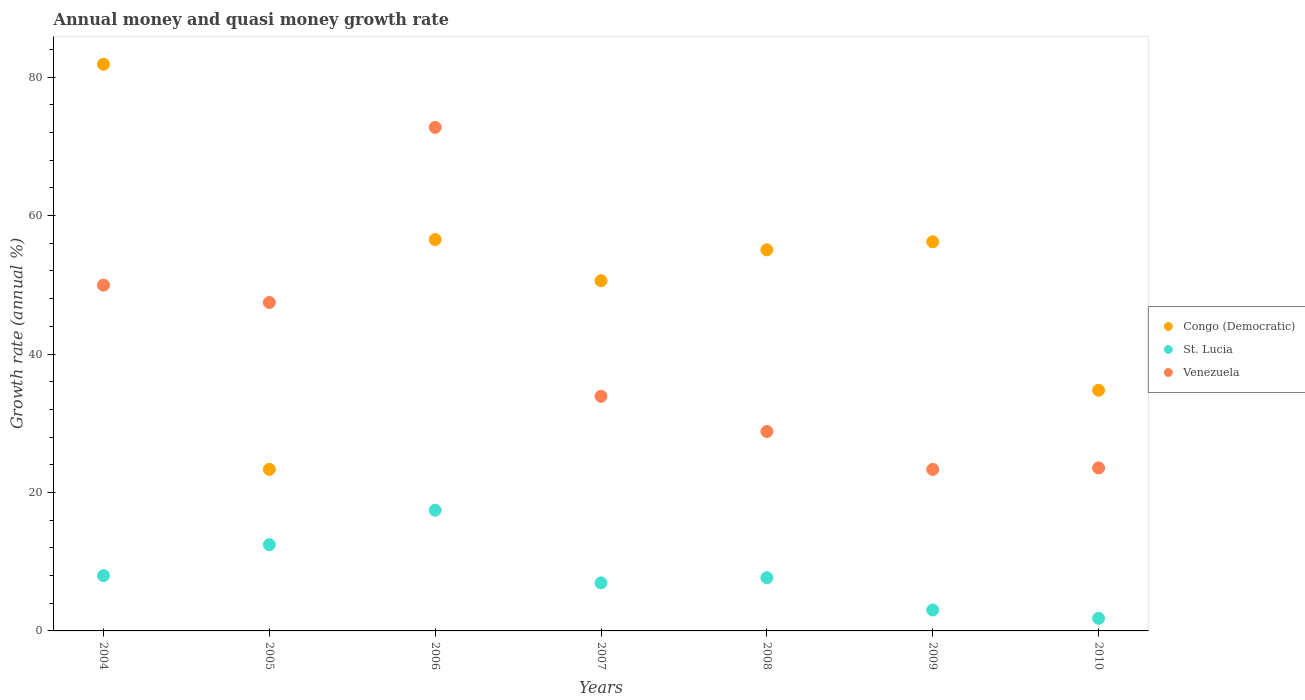Is the number of dotlines equal to the number of legend labels?
Keep it short and to the point. Yes. What is the growth rate in St. Lucia in 2009?
Your answer should be very brief. 3.03. Across all years, what is the maximum growth rate in Venezuela?
Ensure brevity in your answer.  72.74. Across all years, what is the minimum growth rate in Venezuela?
Make the answer very short. 23.33. In which year was the growth rate in Venezuela maximum?
Ensure brevity in your answer.  2006. What is the total growth rate in St. Lucia in the graph?
Ensure brevity in your answer.  57.36. What is the difference between the growth rate in St. Lucia in 2007 and that in 2010?
Your response must be concise. 5.12. What is the difference between the growth rate in St. Lucia in 2007 and the growth rate in Venezuela in 2008?
Your answer should be compact. -21.86. What is the average growth rate in Venezuela per year?
Offer a terse response. 39.96. In the year 2005, what is the difference between the growth rate in Congo (Democratic) and growth rate in Venezuela?
Your response must be concise. -24.1. In how many years, is the growth rate in St. Lucia greater than 76 %?
Make the answer very short. 0. What is the ratio of the growth rate in Congo (Democratic) in 2004 to that in 2009?
Give a very brief answer. 1.46. Is the difference between the growth rate in Congo (Democratic) in 2005 and 2010 greater than the difference between the growth rate in Venezuela in 2005 and 2010?
Make the answer very short. No. What is the difference between the highest and the second highest growth rate in St. Lucia?
Ensure brevity in your answer.  4.98. What is the difference between the highest and the lowest growth rate in Venezuela?
Keep it short and to the point. 49.4. In how many years, is the growth rate in St. Lucia greater than the average growth rate in St. Lucia taken over all years?
Provide a succinct answer. 2. Does the growth rate in Congo (Democratic) monotonically increase over the years?
Your answer should be very brief. No. How many dotlines are there?
Make the answer very short. 3. What is the difference between two consecutive major ticks on the Y-axis?
Give a very brief answer. 20. Does the graph contain any zero values?
Give a very brief answer. No. Where does the legend appear in the graph?
Offer a very short reply. Center right. How many legend labels are there?
Offer a very short reply. 3. How are the legend labels stacked?
Offer a terse response. Vertical. What is the title of the graph?
Ensure brevity in your answer.  Annual money and quasi money growth rate. Does "Iran" appear as one of the legend labels in the graph?
Ensure brevity in your answer.  No. What is the label or title of the X-axis?
Your response must be concise. Years. What is the label or title of the Y-axis?
Your answer should be very brief. Growth rate (annual %). What is the Growth rate (annual %) in Congo (Democratic) in 2004?
Give a very brief answer. 81.85. What is the Growth rate (annual %) of St. Lucia in 2004?
Give a very brief answer. 7.99. What is the Growth rate (annual %) of Venezuela in 2004?
Make the answer very short. 49.95. What is the Growth rate (annual %) of Congo (Democratic) in 2005?
Your answer should be compact. 23.34. What is the Growth rate (annual %) in St. Lucia in 2005?
Make the answer very short. 12.46. What is the Growth rate (annual %) in Venezuela in 2005?
Make the answer very short. 47.44. What is the Growth rate (annual %) in Congo (Democratic) in 2006?
Your response must be concise. 56.53. What is the Growth rate (annual %) of St. Lucia in 2006?
Your response must be concise. 17.43. What is the Growth rate (annual %) of Venezuela in 2006?
Your response must be concise. 72.74. What is the Growth rate (annual %) of Congo (Democratic) in 2007?
Keep it short and to the point. 50.59. What is the Growth rate (annual %) in St. Lucia in 2007?
Your response must be concise. 6.95. What is the Growth rate (annual %) in Venezuela in 2007?
Provide a short and direct response. 33.89. What is the Growth rate (annual %) of Congo (Democratic) in 2008?
Your answer should be very brief. 55.05. What is the Growth rate (annual %) in St. Lucia in 2008?
Make the answer very short. 7.69. What is the Growth rate (annual %) of Venezuela in 2008?
Ensure brevity in your answer.  28.8. What is the Growth rate (annual %) in Congo (Democratic) in 2009?
Keep it short and to the point. 56.21. What is the Growth rate (annual %) in St. Lucia in 2009?
Offer a terse response. 3.03. What is the Growth rate (annual %) in Venezuela in 2009?
Your answer should be compact. 23.33. What is the Growth rate (annual %) in Congo (Democratic) in 2010?
Offer a terse response. 34.76. What is the Growth rate (annual %) of St. Lucia in 2010?
Your response must be concise. 1.82. What is the Growth rate (annual %) of Venezuela in 2010?
Ensure brevity in your answer.  23.55. Across all years, what is the maximum Growth rate (annual %) of Congo (Democratic)?
Your response must be concise. 81.85. Across all years, what is the maximum Growth rate (annual %) of St. Lucia?
Give a very brief answer. 17.43. Across all years, what is the maximum Growth rate (annual %) in Venezuela?
Offer a very short reply. 72.74. Across all years, what is the minimum Growth rate (annual %) in Congo (Democratic)?
Your response must be concise. 23.34. Across all years, what is the minimum Growth rate (annual %) of St. Lucia?
Keep it short and to the point. 1.82. Across all years, what is the minimum Growth rate (annual %) in Venezuela?
Ensure brevity in your answer.  23.33. What is the total Growth rate (annual %) of Congo (Democratic) in the graph?
Offer a terse response. 358.34. What is the total Growth rate (annual %) of St. Lucia in the graph?
Your answer should be compact. 57.36. What is the total Growth rate (annual %) of Venezuela in the graph?
Offer a very short reply. 279.7. What is the difference between the Growth rate (annual %) of Congo (Democratic) in 2004 and that in 2005?
Your answer should be very brief. 58.51. What is the difference between the Growth rate (annual %) in St. Lucia in 2004 and that in 2005?
Make the answer very short. -4.47. What is the difference between the Growth rate (annual %) of Venezuela in 2004 and that in 2005?
Make the answer very short. 2.51. What is the difference between the Growth rate (annual %) in Congo (Democratic) in 2004 and that in 2006?
Your response must be concise. 25.32. What is the difference between the Growth rate (annual %) of St. Lucia in 2004 and that in 2006?
Provide a short and direct response. -9.44. What is the difference between the Growth rate (annual %) in Venezuela in 2004 and that in 2006?
Offer a very short reply. -22.78. What is the difference between the Growth rate (annual %) in Congo (Democratic) in 2004 and that in 2007?
Ensure brevity in your answer.  31.27. What is the difference between the Growth rate (annual %) in St. Lucia in 2004 and that in 2007?
Your answer should be compact. 1.05. What is the difference between the Growth rate (annual %) in Venezuela in 2004 and that in 2007?
Your answer should be compact. 16.06. What is the difference between the Growth rate (annual %) of Congo (Democratic) in 2004 and that in 2008?
Offer a very short reply. 26.8. What is the difference between the Growth rate (annual %) of St. Lucia in 2004 and that in 2008?
Offer a very short reply. 0.3. What is the difference between the Growth rate (annual %) in Venezuela in 2004 and that in 2008?
Ensure brevity in your answer.  21.15. What is the difference between the Growth rate (annual %) in Congo (Democratic) in 2004 and that in 2009?
Ensure brevity in your answer.  25.64. What is the difference between the Growth rate (annual %) in St. Lucia in 2004 and that in 2009?
Provide a short and direct response. 4.96. What is the difference between the Growth rate (annual %) in Venezuela in 2004 and that in 2009?
Offer a very short reply. 26.62. What is the difference between the Growth rate (annual %) of Congo (Democratic) in 2004 and that in 2010?
Offer a very short reply. 47.09. What is the difference between the Growth rate (annual %) of St. Lucia in 2004 and that in 2010?
Your response must be concise. 6.17. What is the difference between the Growth rate (annual %) of Venezuela in 2004 and that in 2010?
Make the answer very short. 26.41. What is the difference between the Growth rate (annual %) in Congo (Democratic) in 2005 and that in 2006?
Give a very brief answer. -33.19. What is the difference between the Growth rate (annual %) of St. Lucia in 2005 and that in 2006?
Provide a succinct answer. -4.98. What is the difference between the Growth rate (annual %) of Venezuela in 2005 and that in 2006?
Provide a short and direct response. -25.3. What is the difference between the Growth rate (annual %) of Congo (Democratic) in 2005 and that in 2007?
Offer a terse response. -27.25. What is the difference between the Growth rate (annual %) in St. Lucia in 2005 and that in 2007?
Offer a very short reply. 5.51. What is the difference between the Growth rate (annual %) in Venezuela in 2005 and that in 2007?
Your answer should be very brief. 13.55. What is the difference between the Growth rate (annual %) in Congo (Democratic) in 2005 and that in 2008?
Ensure brevity in your answer.  -31.71. What is the difference between the Growth rate (annual %) of St. Lucia in 2005 and that in 2008?
Your response must be concise. 4.77. What is the difference between the Growth rate (annual %) in Venezuela in 2005 and that in 2008?
Give a very brief answer. 18.64. What is the difference between the Growth rate (annual %) in Congo (Democratic) in 2005 and that in 2009?
Offer a terse response. -32.87. What is the difference between the Growth rate (annual %) in St. Lucia in 2005 and that in 2009?
Make the answer very short. 9.43. What is the difference between the Growth rate (annual %) of Venezuela in 2005 and that in 2009?
Your answer should be very brief. 24.11. What is the difference between the Growth rate (annual %) in Congo (Democratic) in 2005 and that in 2010?
Offer a terse response. -11.42. What is the difference between the Growth rate (annual %) in St. Lucia in 2005 and that in 2010?
Provide a succinct answer. 10.63. What is the difference between the Growth rate (annual %) of Venezuela in 2005 and that in 2010?
Your response must be concise. 23.89. What is the difference between the Growth rate (annual %) in Congo (Democratic) in 2006 and that in 2007?
Provide a short and direct response. 5.94. What is the difference between the Growth rate (annual %) in St. Lucia in 2006 and that in 2007?
Give a very brief answer. 10.49. What is the difference between the Growth rate (annual %) in Venezuela in 2006 and that in 2007?
Ensure brevity in your answer.  38.84. What is the difference between the Growth rate (annual %) in Congo (Democratic) in 2006 and that in 2008?
Ensure brevity in your answer.  1.48. What is the difference between the Growth rate (annual %) in St. Lucia in 2006 and that in 2008?
Make the answer very short. 9.74. What is the difference between the Growth rate (annual %) in Venezuela in 2006 and that in 2008?
Offer a very short reply. 43.94. What is the difference between the Growth rate (annual %) of Congo (Democratic) in 2006 and that in 2009?
Provide a short and direct response. 0.32. What is the difference between the Growth rate (annual %) of St. Lucia in 2006 and that in 2009?
Give a very brief answer. 14.4. What is the difference between the Growth rate (annual %) of Venezuela in 2006 and that in 2009?
Keep it short and to the point. 49.4. What is the difference between the Growth rate (annual %) in Congo (Democratic) in 2006 and that in 2010?
Your answer should be very brief. 21.77. What is the difference between the Growth rate (annual %) in St. Lucia in 2006 and that in 2010?
Provide a succinct answer. 15.61. What is the difference between the Growth rate (annual %) of Venezuela in 2006 and that in 2010?
Keep it short and to the point. 49.19. What is the difference between the Growth rate (annual %) of Congo (Democratic) in 2007 and that in 2008?
Your response must be concise. -4.46. What is the difference between the Growth rate (annual %) in St. Lucia in 2007 and that in 2008?
Your answer should be compact. -0.74. What is the difference between the Growth rate (annual %) in Venezuela in 2007 and that in 2008?
Offer a very short reply. 5.09. What is the difference between the Growth rate (annual %) of Congo (Democratic) in 2007 and that in 2009?
Provide a short and direct response. -5.63. What is the difference between the Growth rate (annual %) of St. Lucia in 2007 and that in 2009?
Offer a very short reply. 3.92. What is the difference between the Growth rate (annual %) of Venezuela in 2007 and that in 2009?
Your answer should be very brief. 10.56. What is the difference between the Growth rate (annual %) of Congo (Democratic) in 2007 and that in 2010?
Ensure brevity in your answer.  15.82. What is the difference between the Growth rate (annual %) in St. Lucia in 2007 and that in 2010?
Provide a succinct answer. 5.12. What is the difference between the Growth rate (annual %) in Venezuela in 2007 and that in 2010?
Ensure brevity in your answer.  10.35. What is the difference between the Growth rate (annual %) of Congo (Democratic) in 2008 and that in 2009?
Ensure brevity in your answer.  -1.16. What is the difference between the Growth rate (annual %) of St. Lucia in 2008 and that in 2009?
Give a very brief answer. 4.66. What is the difference between the Growth rate (annual %) in Venezuela in 2008 and that in 2009?
Offer a very short reply. 5.47. What is the difference between the Growth rate (annual %) of Congo (Democratic) in 2008 and that in 2010?
Keep it short and to the point. 20.29. What is the difference between the Growth rate (annual %) in St. Lucia in 2008 and that in 2010?
Keep it short and to the point. 5.87. What is the difference between the Growth rate (annual %) of Venezuela in 2008 and that in 2010?
Offer a terse response. 5.25. What is the difference between the Growth rate (annual %) of Congo (Democratic) in 2009 and that in 2010?
Ensure brevity in your answer.  21.45. What is the difference between the Growth rate (annual %) of St. Lucia in 2009 and that in 2010?
Make the answer very short. 1.21. What is the difference between the Growth rate (annual %) in Venezuela in 2009 and that in 2010?
Keep it short and to the point. -0.21. What is the difference between the Growth rate (annual %) in Congo (Democratic) in 2004 and the Growth rate (annual %) in St. Lucia in 2005?
Make the answer very short. 69.4. What is the difference between the Growth rate (annual %) in Congo (Democratic) in 2004 and the Growth rate (annual %) in Venezuela in 2005?
Offer a terse response. 34.41. What is the difference between the Growth rate (annual %) of St. Lucia in 2004 and the Growth rate (annual %) of Venezuela in 2005?
Ensure brevity in your answer.  -39.45. What is the difference between the Growth rate (annual %) in Congo (Democratic) in 2004 and the Growth rate (annual %) in St. Lucia in 2006?
Provide a succinct answer. 64.42. What is the difference between the Growth rate (annual %) of Congo (Democratic) in 2004 and the Growth rate (annual %) of Venezuela in 2006?
Provide a succinct answer. 9.12. What is the difference between the Growth rate (annual %) of St. Lucia in 2004 and the Growth rate (annual %) of Venezuela in 2006?
Make the answer very short. -64.75. What is the difference between the Growth rate (annual %) in Congo (Democratic) in 2004 and the Growth rate (annual %) in St. Lucia in 2007?
Ensure brevity in your answer.  74.91. What is the difference between the Growth rate (annual %) in Congo (Democratic) in 2004 and the Growth rate (annual %) in Venezuela in 2007?
Give a very brief answer. 47.96. What is the difference between the Growth rate (annual %) of St. Lucia in 2004 and the Growth rate (annual %) of Venezuela in 2007?
Keep it short and to the point. -25.9. What is the difference between the Growth rate (annual %) of Congo (Democratic) in 2004 and the Growth rate (annual %) of St. Lucia in 2008?
Keep it short and to the point. 74.17. What is the difference between the Growth rate (annual %) of Congo (Democratic) in 2004 and the Growth rate (annual %) of Venezuela in 2008?
Provide a short and direct response. 53.05. What is the difference between the Growth rate (annual %) of St. Lucia in 2004 and the Growth rate (annual %) of Venezuela in 2008?
Your response must be concise. -20.81. What is the difference between the Growth rate (annual %) in Congo (Democratic) in 2004 and the Growth rate (annual %) in St. Lucia in 2009?
Your answer should be compact. 78.83. What is the difference between the Growth rate (annual %) of Congo (Democratic) in 2004 and the Growth rate (annual %) of Venezuela in 2009?
Offer a terse response. 58.52. What is the difference between the Growth rate (annual %) of St. Lucia in 2004 and the Growth rate (annual %) of Venezuela in 2009?
Provide a short and direct response. -15.34. What is the difference between the Growth rate (annual %) in Congo (Democratic) in 2004 and the Growth rate (annual %) in St. Lucia in 2010?
Provide a short and direct response. 80.03. What is the difference between the Growth rate (annual %) of Congo (Democratic) in 2004 and the Growth rate (annual %) of Venezuela in 2010?
Your response must be concise. 58.31. What is the difference between the Growth rate (annual %) of St. Lucia in 2004 and the Growth rate (annual %) of Venezuela in 2010?
Your answer should be compact. -15.56. What is the difference between the Growth rate (annual %) in Congo (Democratic) in 2005 and the Growth rate (annual %) in St. Lucia in 2006?
Ensure brevity in your answer.  5.91. What is the difference between the Growth rate (annual %) of Congo (Democratic) in 2005 and the Growth rate (annual %) of Venezuela in 2006?
Make the answer very short. -49.4. What is the difference between the Growth rate (annual %) in St. Lucia in 2005 and the Growth rate (annual %) in Venezuela in 2006?
Make the answer very short. -60.28. What is the difference between the Growth rate (annual %) in Congo (Democratic) in 2005 and the Growth rate (annual %) in St. Lucia in 2007?
Offer a terse response. 16.4. What is the difference between the Growth rate (annual %) of Congo (Democratic) in 2005 and the Growth rate (annual %) of Venezuela in 2007?
Your response must be concise. -10.55. What is the difference between the Growth rate (annual %) in St. Lucia in 2005 and the Growth rate (annual %) in Venezuela in 2007?
Keep it short and to the point. -21.44. What is the difference between the Growth rate (annual %) of Congo (Democratic) in 2005 and the Growth rate (annual %) of St. Lucia in 2008?
Give a very brief answer. 15.65. What is the difference between the Growth rate (annual %) in Congo (Democratic) in 2005 and the Growth rate (annual %) in Venezuela in 2008?
Offer a very short reply. -5.46. What is the difference between the Growth rate (annual %) of St. Lucia in 2005 and the Growth rate (annual %) of Venezuela in 2008?
Ensure brevity in your answer.  -16.34. What is the difference between the Growth rate (annual %) of Congo (Democratic) in 2005 and the Growth rate (annual %) of St. Lucia in 2009?
Offer a terse response. 20.31. What is the difference between the Growth rate (annual %) of Congo (Democratic) in 2005 and the Growth rate (annual %) of Venezuela in 2009?
Make the answer very short. 0.01. What is the difference between the Growth rate (annual %) of St. Lucia in 2005 and the Growth rate (annual %) of Venezuela in 2009?
Your response must be concise. -10.88. What is the difference between the Growth rate (annual %) of Congo (Democratic) in 2005 and the Growth rate (annual %) of St. Lucia in 2010?
Your response must be concise. 21.52. What is the difference between the Growth rate (annual %) in Congo (Democratic) in 2005 and the Growth rate (annual %) in Venezuela in 2010?
Your answer should be very brief. -0.21. What is the difference between the Growth rate (annual %) in St. Lucia in 2005 and the Growth rate (annual %) in Venezuela in 2010?
Offer a terse response. -11.09. What is the difference between the Growth rate (annual %) of Congo (Democratic) in 2006 and the Growth rate (annual %) of St. Lucia in 2007?
Provide a succinct answer. 49.59. What is the difference between the Growth rate (annual %) of Congo (Democratic) in 2006 and the Growth rate (annual %) of Venezuela in 2007?
Your answer should be compact. 22.64. What is the difference between the Growth rate (annual %) in St. Lucia in 2006 and the Growth rate (annual %) in Venezuela in 2007?
Make the answer very short. -16.46. What is the difference between the Growth rate (annual %) in Congo (Democratic) in 2006 and the Growth rate (annual %) in St. Lucia in 2008?
Your answer should be compact. 48.84. What is the difference between the Growth rate (annual %) in Congo (Democratic) in 2006 and the Growth rate (annual %) in Venezuela in 2008?
Ensure brevity in your answer.  27.73. What is the difference between the Growth rate (annual %) of St. Lucia in 2006 and the Growth rate (annual %) of Venezuela in 2008?
Your answer should be very brief. -11.37. What is the difference between the Growth rate (annual %) of Congo (Democratic) in 2006 and the Growth rate (annual %) of St. Lucia in 2009?
Provide a succinct answer. 53.5. What is the difference between the Growth rate (annual %) in Congo (Democratic) in 2006 and the Growth rate (annual %) in Venezuela in 2009?
Your answer should be compact. 33.2. What is the difference between the Growth rate (annual %) in St. Lucia in 2006 and the Growth rate (annual %) in Venezuela in 2009?
Your answer should be very brief. -5.9. What is the difference between the Growth rate (annual %) of Congo (Democratic) in 2006 and the Growth rate (annual %) of St. Lucia in 2010?
Offer a very short reply. 54.71. What is the difference between the Growth rate (annual %) of Congo (Democratic) in 2006 and the Growth rate (annual %) of Venezuela in 2010?
Make the answer very short. 32.98. What is the difference between the Growth rate (annual %) in St. Lucia in 2006 and the Growth rate (annual %) in Venezuela in 2010?
Offer a terse response. -6.11. What is the difference between the Growth rate (annual %) in Congo (Democratic) in 2007 and the Growth rate (annual %) in St. Lucia in 2008?
Offer a terse response. 42.9. What is the difference between the Growth rate (annual %) in Congo (Democratic) in 2007 and the Growth rate (annual %) in Venezuela in 2008?
Offer a very short reply. 21.79. What is the difference between the Growth rate (annual %) in St. Lucia in 2007 and the Growth rate (annual %) in Venezuela in 2008?
Keep it short and to the point. -21.86. What is the difference between the Growth rate (annual %) in Congo (Democratic) in 2007 and the Growth rate (annual %) in St. Lucia in 2009?
Your response must be concise. 47.56. What is the difference between the Growth rate (annual %) of Congo (Democratic) in 2007 and the Growth rate (annual %) of Venezuela in 2009?
Offer a very short reply. 27.26. What is the difference between the Growth rate (annual %) in St. Lucia in 2007 and the Growth rate (annual %) in Venezuela in 2009?
Offer a terse response. -16.39. What is the difference between the Growth rate (annual %) of Congo (Democratic) in 2007 and the Growth rate (annual %) of St. Lucia in 2010?
Keep it short and to the point. 48.77. What is the difference between the Growth rate (annual %) of Congo (Democratic) in 2007 and the Growth rate (annual %) of Venezuela in 2010?
Ensure brevity in your answer.  27.04. What is the difference between the Growth rate (annual %) in St. Lucia in 2007 and the Growth rate (annual %) in Venezuela in 2010?
Make the answer very short. -16.6. What is the difference between the Growth rate (annual %) in Congo (Democratic) in 2008 and the Growth rate (annual %) in St. Lucia in 2009?
Keep it short and to the point. 52.02. What is the difference between the Growth rate (annual %) of Congo (Democratic) in 2008 and the Growth rate (annual %) of Venezuela in 2009?
Provide a short and direct response. 31.72. What is the difference between the Growth rate (annual %) in St. Lucia in 2008 and the Growth rate (annual %) in Venezuela in 2009?
Provide a short and direct response. -15.64. What is the difference between the Growth rate (annual %) of Congo (Democratic) in 2008 and the Growth rate (annual %) of St. Lucia in 2010?
Your answer should be very brief. 53.23. What is the difference between the Growth rate (annual %) in Congo (Democratic) in 2008 and the Growth rate (annual %) in Venezuela in 2010?
Offer a very short reply. 31.5. What is the difference between the Growth rate (annual %) of St. Lucia in 2008 and the Growth rate (annual %) of Venezuela in 2010?
Offer a terse response. -15.86. What is the difference between the Growth rate (annual %) of Congo (Democratic) in 2009 and the Growth rate (annual %) of St. Lucia in 2010?
Your answer should be very brief. 54.39. What is the difference between the Growth rate (annual %) in Congo (Democratic) in 2009 and the Growth rate (annual %) in Venezuela in 2010?
Offer a very short reply. 32.67. What is the difference between the Growth rate (annual %) in St. Lucia in 2009 and the Growth rate (annual %) in Venezuela in 2010?
Ensure brevity in your answer.  -20.52. What is the average Growth rate (annual %) in Congo (Democratic) per year?
Provide a short and direct response. 51.19. What is the average Growth rate (annual %) of St. Lucia per year?
Provide a succinct answer. 8.19. What is the average Growth rate (annual %) in Venezuela per year?
Give a very brief answer. 39.96. In the year 2004, what is the difference between the Growth rate (annual %) in Congo (Democratic) and Growth rate (annual %) in St. Lucia?
Your answer should be very brief. 73.86. In the year 2004, what is the difference between the Growth rate (annual %) in Congo (Democratic) and Growth rate (annual %) in Venezuela?
Make the answer very short. 31.9. In the year 2004, what is the difference between the Growth rate (annual %) of St. Lucia and Growth rate (annual %) of Venezuela?
Your answer should be very brief. -41.96. In the year 2005, what is the difference between the Growth rate (annual %) of Congo (Democratic) and Growth rate (annual %) of St. Lucia?
Your response must be concise. 10.88. In the year 2005, what is the difference between the Growth rate (annual %) of Congo (Democratic) and Growth rate (annual %) of Venezuela?
Your answer should be very brief. -24.1. In the year 2005, what is the difference between the Growth rate (annual %) of St. Lucia and Growth rate (annual %) of Venezuela?
Provide a short and direct response. -34.98. In the year 2006, what is the difference between the Growth rate (annual %) of Congo (Democratic) and Growth rate (annual %) of St. Lucia?
Make the answer very short. 39.1. In the year 2006, what is the difference between the Growth rate (annual %) in Congo (Democratic) and Growth rate (annual %) in Venezuela?
Make the answer very short. -16.21. In the year 2006, what is the difference between the Growth rate (annual %) in St. Lucia and Growth rate (annual %) in Venezuela?
Make the answer very short. -55.3. In the year 2007, what is the difference between the Growth rate (annual %) in Congo (Democratic) and Growth rate (annual %) in St. Lucia?
Your response must be concise. 43.64. In the year 2007, what is the difference between the Growth rate (annual %) in Congo (Democratic) and Growth rate (annual %) in Venezuela?
Ensure brevity in your answer.  16.69. In the year 2007, what is the difference between the Growth rate (annual %) in St. Lucia and Growth rate (annual %) in Venezuela?
Your response must be concise. -26.95. In the year 2008, what is the difference between the Growth rate (annual %) of Congo (Democratic) and Growth rate (annual %) of St. Lucia?
Offer a very short reply. 47.36. In the year 2008, what is the difference between the Growth rate (annual %) of Congo (Democratic) and Growth rate (annual %) of Venezuela?
Offer a very short reply. 26.25. In the year 2008, what is the difference between the Growth rate (annual %) in St. Lucia and Growth rate (annual %) in Venezuela?
Your answer should be very brief. -21.11. In the year 2009, what is the difference between the Growth rate (annual %) in Congo (Democratic) and Growth rate (annual %) in St. Lucia?
Ensure brevity in your answer.  53.19. In the year 2009, what is the difference between the Growth rate (annual %) in Congo (Democratic) and Growth rate (annual %) in Venezuela?
Your response must be concise. 32.88. In the year 2009, what is the difference between the Growth rate (annual %) in St. Lucia and Growth rate (annual %) in Venezuela?
Give a very brief answer. -20.3. In the year 2010, what is the difference between the Growth rate (annual %) of Congo (Democratic) and Growth rate (annual %) of St. Lucia?
Provide a short and direct response. 32.94. In the year 2010, what is the difference between the Growth rate (annual %) of Congo (Democratic) and Growth rate (annual %) of Venezuela?
Offer a terse response. 11.22. In the year 2010, what is the difference between the Growth rate (annual %) in St. Lucia and Growth rate (annual %) in Venezuela?
Give a very brief answer. -21.73. What is the ratio of the Growth rate (annual %) of Congo (Democratic) in 2004 to that in 2005?
Keep it short and to the point. 3.51. What is the ratio of the Growth rate (annual %) of St. Lucia in 2004 to that in 2005?
Your answer should be compact. 0.64. What is the ratio of the Growth rate (annual %) in Venezuela in 2004 to that in 2005?
Give a very brief answer. 1.05. What is the ratio of the Growth rate (annual %) of Congo (Democratic) in 2004 to that in 2006?
Keep it short and to the point. 1.45. What is the ratio of the Growth rate (annual %) of St. Lucia in 2004 to that in 2006?
Your answer should be very brief. 0.46. What is the ratio of the Growth rate (annual %) in Venezuela in 2004 to that in 2006?
Provide a succinct answer. 0.69. What is the ratio of the Growth rate (annual %) of Congo (Democratic) in 2004 to that in 2007?
Provide a short and direct response. 1.62. What is the ratio of the Growth rate (annual %) in St. Lucia in 2004 to that in 2007?
Provide a short and direct response. 1.15. What is the ratio of the Growth rate (annual %) in Venezuela in 2004 to that in 2007?
Provide a succinct answer. 1.47. What is the ratio of the Growth rate (annual %) in Congo (Democratic) in 2004 to that in 2008?
Your answer should be compact. 1.49. What is the ratio of the Growth rate (annual %) of St. Lucia in 2004 to that in 2008?
Make the answer very short. 1.04. What is the ratio of the Growth rate (annual %) in Venezuela in 2004 to that in 2008?
Give a very brief answer. 1.73. What is the ratio of the Growth rate (annual %) in Congo (Democratic) in 2004 to that in 2009?
Your response must be concise. 1.46. What is the ratio of the Growth rate (annual %) of St. Lucia in 2004 to that in 2009?
Offer a terse response. 2.64. What is the ratio of the Growth rate (annual %) in Venezuela in 2004 to that in 2009?
Your answer should be compact. 2.14. What is the ratio of the Growth rate (annual %) in Congo (Democratic) in 2004 to that in 2010?
Offer a very short reply. 2.35. What is the ratio of the Growth rate (annual %) in St. Lucia in 2004 to that in 2010?
Your answer should be compact. 4.39. What is the ratio of the Growth rate (annual %) in Venezuela in 2004 to that in 2010?
Your answer should be very brief. 2.12. What is the ratio of the Growth rate (annual %) of Congo (Democratic) in 2005 to that in 2006?
Give a very brief answer. 0.41. What is the ratio of the Growth rate (annual %) of St. Lucia in 2005 to that in 2006?
Your answer should be very brief. 0.71. What is the ratio of the Growth rate (annual %) in Venezuela in 2005 to that in 2006?
Make the answer very short. 0.65. What is the ratio of the Growth rate (annual %) of Congo (Democratic) in 2005 to that in 2007?
Your answer should be compact. 0.46. What is the ratio of the Growth rate (annual %) in St. Lucia in 2005 to that in 2007?
Give a very brief answer. 1.79. What is the ratio of the Growth rate (annual %) of Venezuela in 2005 to that in 2007?
Your answer should be compact. 1.4. What is the ratio of the Growth rate (annual %) in Congo (Democratic) in 2005 to that in 2008?
Your response must be concise. 0.42. What is the ratio of the Growth rate (annual %) in St. Lucia in 2005 to that in 2008?
Make the answer very short. 1.62. What is the ratio of the Growth rate (annual %) of Venezuela in 2005 to that in 2008?
Your response must be concise. 1.65. What is the ratio of the Growth rate (annual %) of Congo (Democratic) in 2005 to that in 2009?
Provide a short and direct response. 0.42. What is the ratio of the Growth rate (annual %) in St. Lucia in 2005 to that in 2009?
Provide a short and direct response. 4.11. What is the ratio of the Growth rate (annual %) in Venezuela in 2005 to that in 2009?
Give a very brief answer. 2.03. What is the ratio of the Growth rate (annual %) in Congo (Democratic) in 2005 to that in 2010?
Ensure brevity in your answer.  0.67. What is the ratio of the Growth rate (annual %) in St. Lucia in 2005 to that in 2010?
Offer a terse response. 6.84. What is the ratio of the Growth rate (annual %) of Venezuela in 2005 to that in 2010?
Give a very brief answer. 2.01. What is the ratio of the Growth rate (annual %) of Congo (Democratic) in 2006 to that in 2007?
Your answer should be compact. 1.12. What is the ratio of the Growth rate (annual %) of St. Lucia in 2006 to that in 2007?
Provide a short and direct response. 2.51. What is the ratio of the Growth rate (annual %) of Venezuela in 2006 to that in 2007?
Ensure brevity in your answer.  2.15. What is the ratio of the Growth rate (annual %) in Congo (Democratic) in 2006 to that in 2008?
Your answer should be compact. 1.03. What is the ratio of the Growth rate (annual %) of St. Lucia in 2006 to that in 2008?
Provide a short and direct response. 2.27. What is the ratio of the Growth rate (annual %) of Venezuela in 2006 to that in 2008?
Your answer should be very brief. 2.53. What is the ratio of the Growth rate (annual %) in Congo (Democratic) in 2006 to that in 2009?
Provide a succinct answer. 1.01. What is the ratio of the Growth rate (annual %) of St. Lucia in 2006 to that in 2009?
Ensure brevity in your answer.  5.76. What is the ratio of the Growth rate (annual %) of Venezuela in 2006 to that in 2009?
Give a very brief answer. 3.12. What is the ratio of the Growth rate (annual %) of Congo (Democratic) in 2006 to that in 2010?
Your answer should be compact. 1.63. What is the ratio of the Growth rate (annual %) in St. Lucia in 2006 to that in 2010?
Provide a short and direct response. 9.57. What is the ratio of the Growth rate (annual %) of Venezuela in 2006 to that in 2010?
Keep it short and to the point. 3.09. What is the ratio of the Growth rate (annual %) in Congo (Democratic) in 2007 to that in 2008?
Your response must be concise. 0.92. What is the ratio of the Growth rate (annual %) of St. Lucia in 2007 to that in 2008?
Offer a terse response. 0.9. What is the ratio of the Growth rate (annual %) in Venezuela in 2007 to that in 2008?
Provide a short and direct response. 1.18. What is the ratio of the Growth rate (annual %) of Congo (Democratic) in 2007 to that in 2009?
Your answer should be very brief. 0.9. What is the ratio of the Growth rate (annual %) in St. Lucia in 2007 to that in 2009?
Provide a succinct answer. 2.29. What is the ratio of the Growth rate (annual %) in Venezuela in 2007 to that in 2009?
Offer a terse response. 1.45. What is the ratio of the Growth rate (annual %) in Congo (Democratic) in 2007 to that in 2010?
Provide a short and direct response. 1.46. What is the ratio of the Growth rate (annual %) in St. Lucia in 2007 to that in 2010?
Offer a very short reply. 3.81. What is the ratio of the Growth rate (annual %) in Venezuela in 2007 to that in 2010?
Your answer should be compact. 1.44. What is the ratio of the Growth rate (annual %) of Congo (Democratic) in 2008 to that in 2009?
Give a very brief answer. 0.98. What is the ratio of the Growth rate (annual %) of St. Lucia in 2008 to that in 2009?
Offer a terse response. 2.54. What is the ratio of the Growth rate (annual %) in Venezuela in 2008 to that in 2009?
Make the answer very short. 1.23. What is the ratio of the Growth rate (annual %) in Congo (Democratic) in 2008 to that in 2010?
Give a very brief answer. 1.58. What is the ratio of the Growth rate (annual %) of St. Lucia in 2008 to that in 2010?
Your response must be concise. 4.22. What is the ratio of the Growth rate (annual %) in Venezuela in 2008 to that in 2010?
Offer a very short reply. 1.22. What is the ratio of the Growth rate (annual %) of Congo (Democratic) in 2009 to that in 2010?
Give a very brief answer. 1.62. What is the ratio of the Growth rate (annual %) of St. Lucia in 2009 to that in 2010?
Give a very brief answer. 1.66. What is the ratio of the Growth rate (annual %) in Venezuela in 2009 to that in 2010?
Your answer should be compact. 0.99. What is the difference between the highest and the second highest Growth rate (annual %) in Congo (Democratic)?
Make the answer very short. 25.32. What is the difference between the highest and the second highest Growth rate (annual %) of St. Lucia?
Your answer should be compact. 4.98. What is the difference between the highest and the second highest Growth rate (annual %) in Venezuela?
Give a very brief answer. 22.78. What is the difference between the highest and the lowest Growth rate (annual %) in Congo (Democratic)?
Your response must be concise. 58.51. What is the difference between the highest and the lowest Growth rate (annual %) in St. Lucia?
Ensure brevity in your answer.  15.61. What is the difference between the highest and the lowest Growth rate (annual %) in Venezuela?
Your answer should be compact. 49.4. 